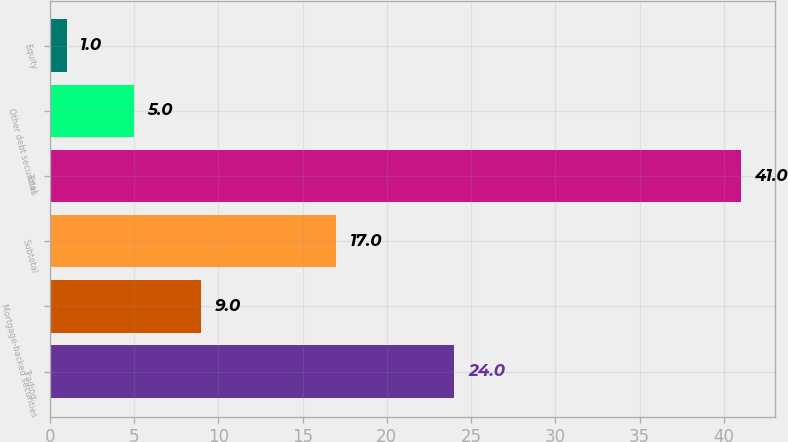Convert chart. <chart><loc_0><loc_0><loc_500><loc_500><bar_chart><fcel>Trading<fcel>Mortgage-backed securities<fcel>Subtotal<fcel>Total<fcel>Other debt securities<fcel>Equity<nl><fcel>24<fcel>9<fcel>17<fcel>41<fcel>5<fcel>1<nl></chart> 